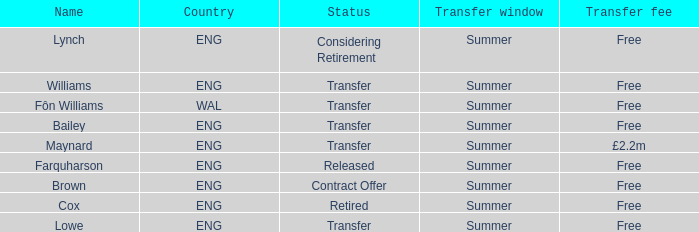What is the title of the free transfer fee in a transfer situation involving an eng nation? Bailey, Williams, Lowe. 